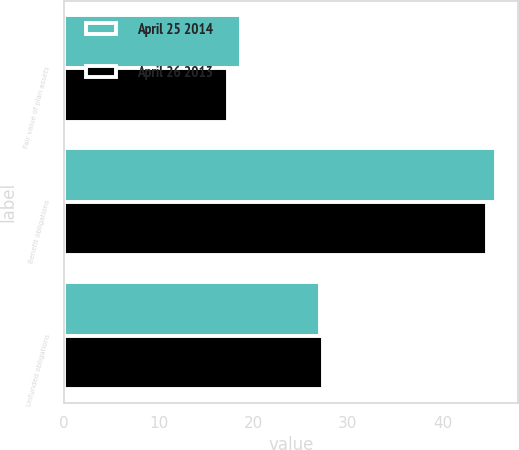<chart> <loc_0><loc_0><loc_500><loc_500><stacked_bar_chart><ecel><fcel>Fair value of plan assets<fcel>Benefit obligations<fcel>Unfunded obligations<nl><fcel>April 25 2014<fcel>18.7<fcel>45.7<fcel>27<nl><fcel>April 26 2013<fcel>17.3<fcel>44.7<fcel>27.4<nl></chart> 